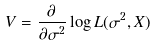<formula> <loc_0><loc_0><loc_500><loc_500>V = { \frac { \partial } { \partial \sigma ^ { 2 } } } \log L ( \sigma ^ { 2 } , X )</formula> 